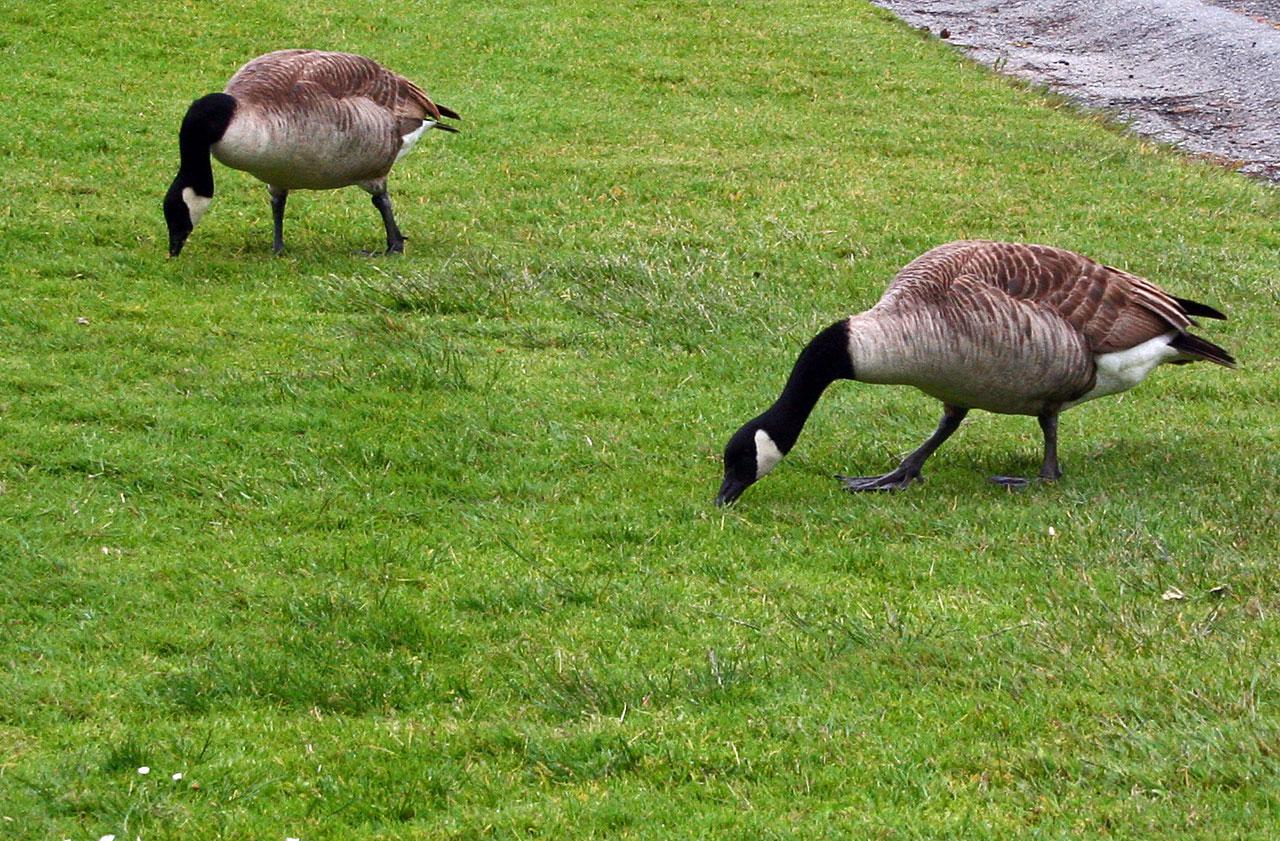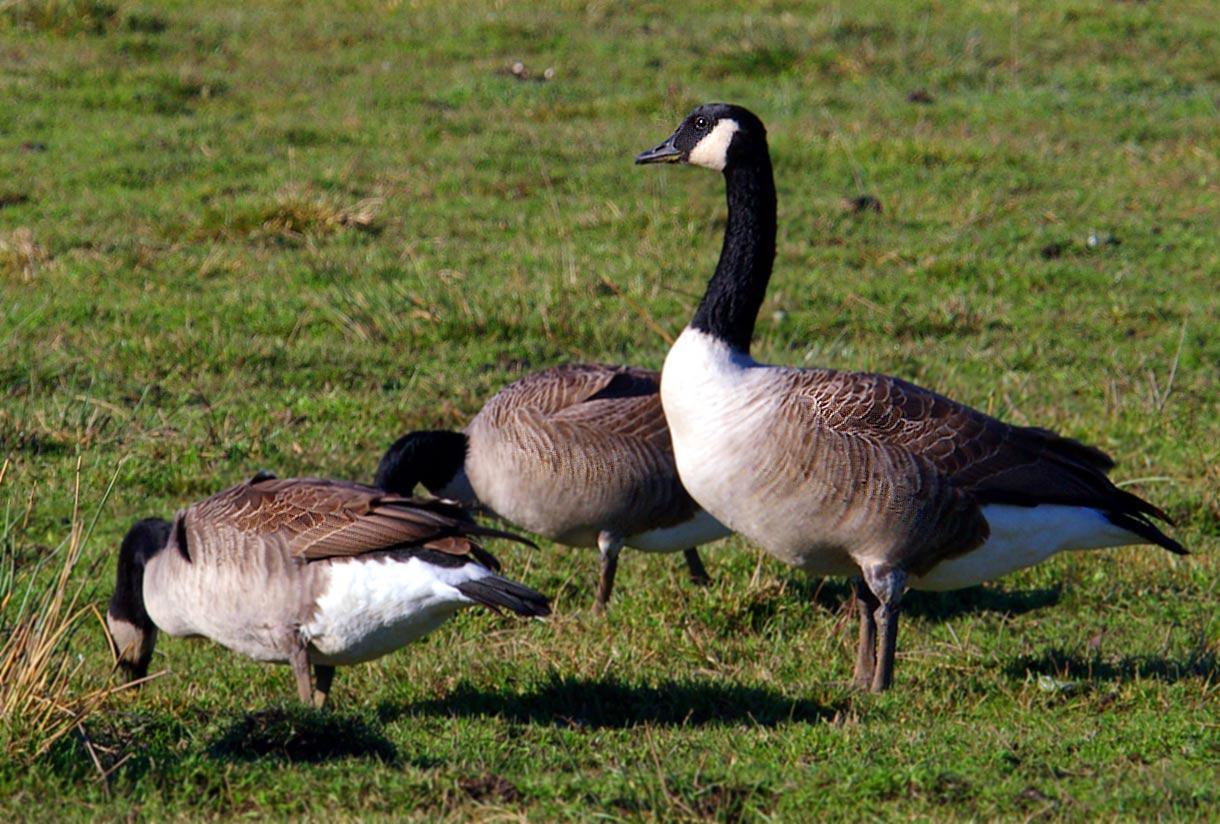The first image is the image on the left, the second image is the image on the right. For the images shown, is this caption "All geese have black necks, and one image contains at least twice as many geese as the other image." true? Answer yes or no. No. The first image is the image on the left, the second image is the image on the right. Considering the images on both sides, is "The right image contains exactly one duck." valid? Answer yes or no. No. 